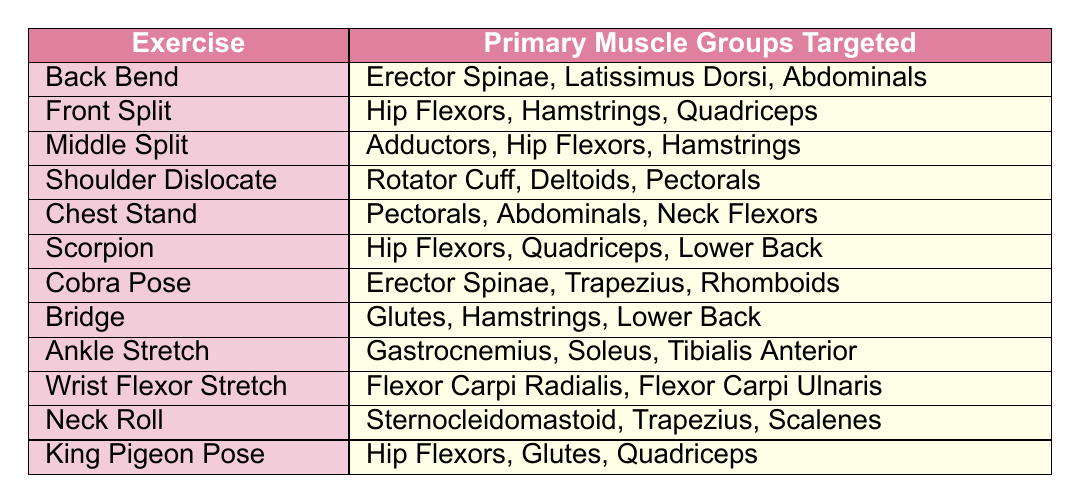What muscle groups are targeted by the Back Bend exercise? The table lists the primary muscle groups targeted by the Back Bend exercise as Erector Spinae, Latissimus Dorsi, and Abdominals.
Answer: Erector Spinae, Latissimus Dorsi, Abdominals Which stretching exercises target the Hip Flexors? The table shows that the Front Split, Middle Split, Scorpion, King Pigeon Pose target the Hip Flexors.
Answer: Front Split, Middle Split, Scorpion, King Pigeon Pose How many exercises target the Quadriceps muscle group? By reviewing the table, we see that Front Split, Scorpion, and King Pigeon Pose target the Quadriceps, totaling three exercises.
Answer: 3 Is the Cobra Pose aimed at the Glutes muscle group? Referring to the table, Cobra Pose targets the Erector Spinae, Trapezius, and Rhomboids, with no mention of the Glutes. Therefore, the statement is false.
Answer: No Which exercise is associated with the most muscle groups based on the table? Evaluating the exercises listed, both the Back Bend and Chest Stand target three unique muscle groups. However, no exercise targets more than three muscle groups.
Answer: 3 What is the primary muscle group targeted by the Shoulder Dislocate exercise? Looking at the table, the primary muscle groups targeted by the Shoulder Dislocate are Rotator Cuff, Deltoids, and Pectorals.
Answer: Rotator Cuff, Deltoids, Pectorals Which exercise targets both the Pectorals and Abdominals? The table indicates that the Chest Stand targets both the Pectorals and Abdominals.
Answer: Chest Stand How many exercises stretch muscle groups of the lower body? The exercises targeting lower body muscle groups are Front Split, Middle Split, Scorpion, Bridge, and King Pigeon Pose. This counts to five exercises.
Answer: 5 Are the muscles targeted by the Wrist Flexor Stretch upper or lower body? Upon checking the table, the Wrist Flexor Stretch targets the Flexor Carpi Radialis and Flexor Carpi Ulnaris, which are located in the forearm, indicating it is an upper body stretch.
Answer: Upper body What combination of exercises target both the Hip Flexors and Quadriceps? The exercises Front Split, Scorpion, and King Pigeon Pose target both the Hip Flexors and Quadriceps, allowing for the combination of these two muscle groups through these specific exercises.
Answer: Front Split, Scorpion, King Pigeon Pose 